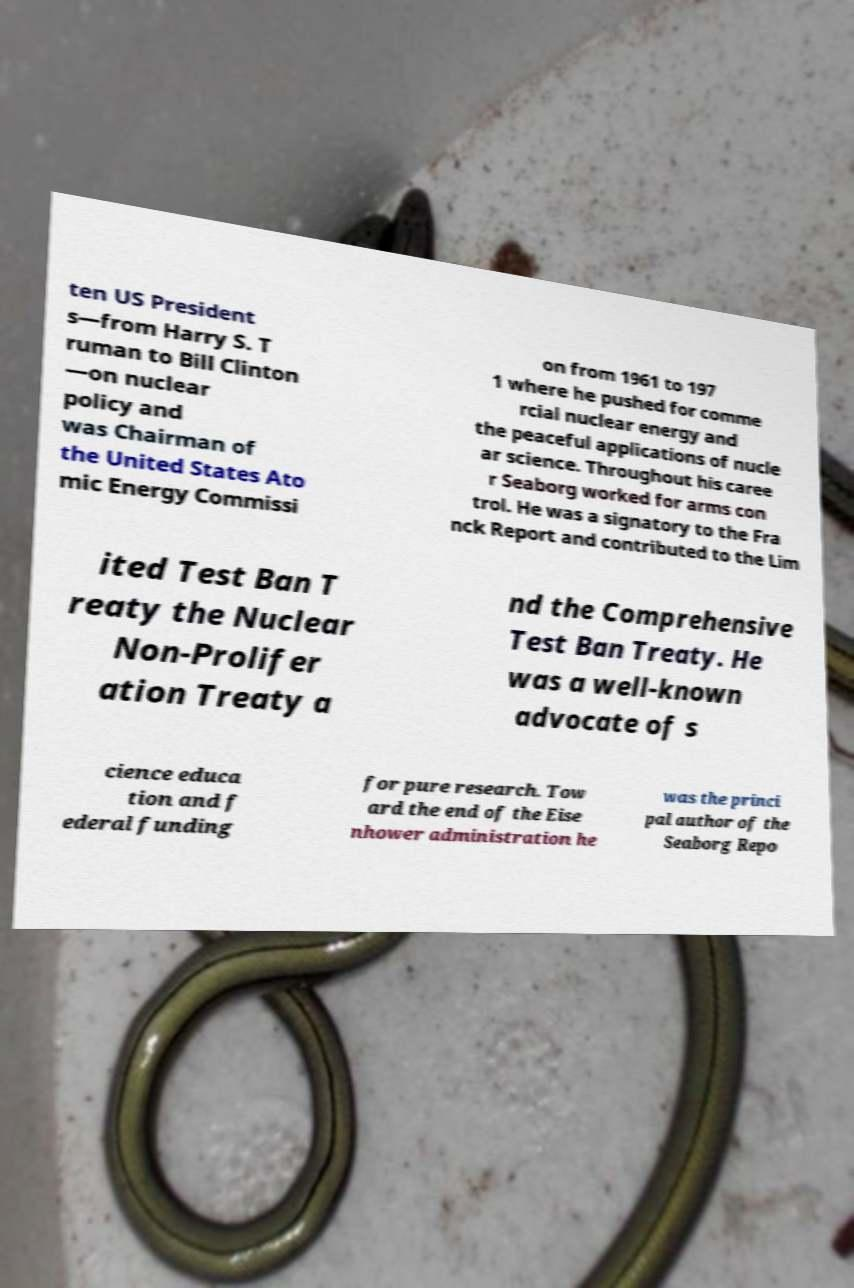There's text embedded in this image that I need extracted. Can you transcribe it verbatim? ten US President s—from Harry S. T ruman to Bill Clinton —on nuclear policy and was Chairman of the United States Ato mic Energy Commissi on from 1961 to 197 1 where he pushed for comme rcial nuclear energy and the peaceful applications of nucle ar science. Throughout his caree r Seaborg worked for arms con trol. He was a signatory to the Fra nck Report and contributed to the Lim ited Test Ban T reaty the Nuclear Non-Prolifer ation Treaty a nd the Comprehensive Test Ban Treaty. He was a well-known advocate of s cience educa tion and f ederal funding for pure research. Tow ard the end of the Eise nhower administration he was the princi pal author of the Seaborg Repo 